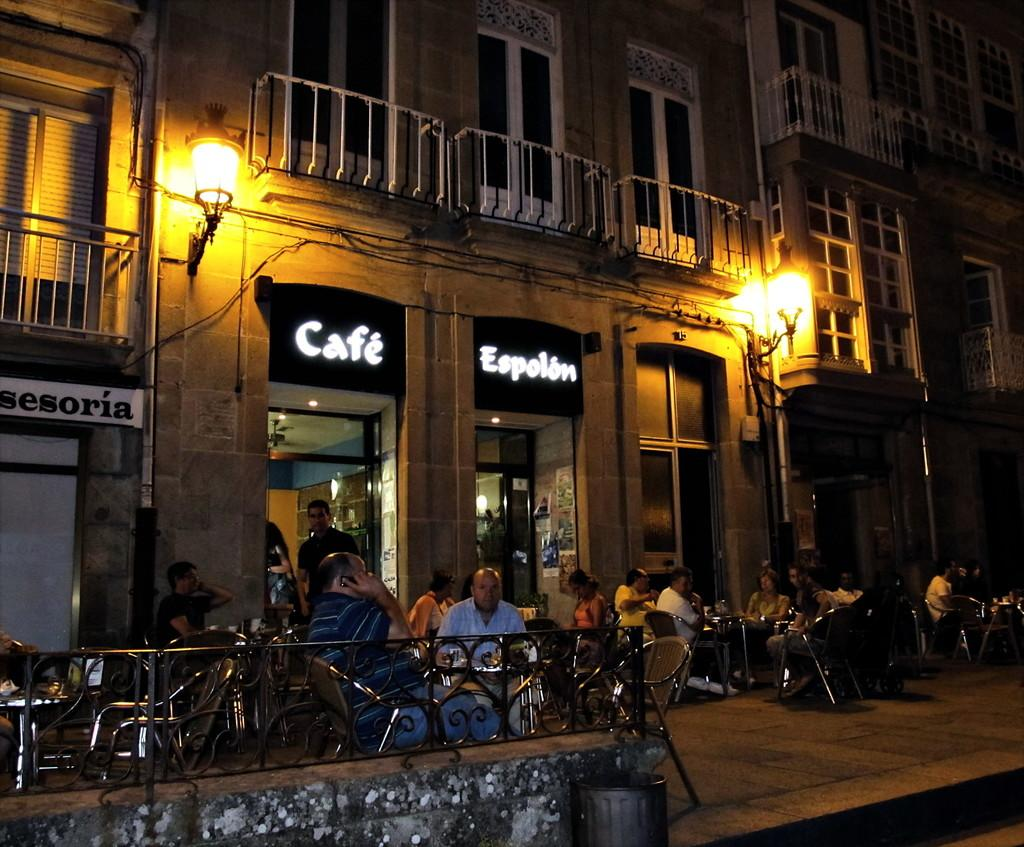Provide a one-sentence caption for the provided image. Two signs over a door that say Cafe and Espolion. 